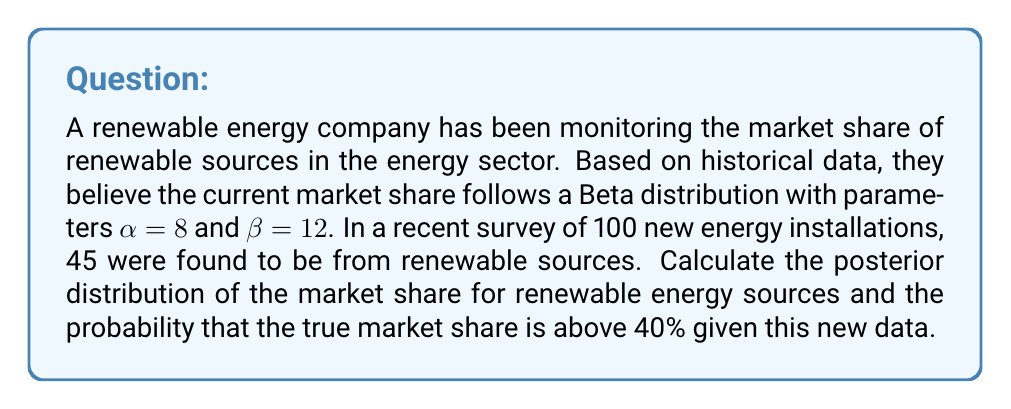Teach me how to tackle this problem. To solve this problem, we'll use Bayesian inference with a Beta-Binomial model:

1) Prior distribution: 
   The prior is Beta($\alpha=8$, $\beta=12$)

2) Likelihood:
   The data follows a Binomial distribution with n=100 and 45 successes

3) Posterior distribution:
   For a Beta prior and Binomial likelihood, the posterior is also a Beta distribution:
   
   Beta($\alpha_{posterior} = \alpha_{prior} + \text{successes}$, $\beta_{posterior} = \beta_{prior} + \text{failures}$)

   $\alpha_{posterior} = 8 + 45 = 53$
   $\beta_{posterior} = 12 + (100 - 45) = 67$

   So, the posterior distribution is Beta(53, 67)

4) Probability that the true market share is above 40%:
   We need to calculate $P(X > 0.4)$ where $X \sim \text{Beta}(53, 67)$

   This can be computed using the cumulative distribution function (CDF) of the Beta distribution:

   $P(X > 0.4) = 1 - P(X \leq 0.4) = 1 - I_{0.4}(53, 67)$

   Where $I_x(a,b)$ is the regularized incomplete beta function.

   Using a statistical software or calculator, we can compute:

   $I_{0.4}(53, 67) \approx 0.0871$

   Therefore, $P(X > 0.4) = 1 - 0.0871 \approx 0.9129$
Answer: The posterior distribution of the market share for renewable energy sources is Beta(53, 67). The probability that the true market share is above 40% given the new data is approximately 0.9129 or 91.29%. 